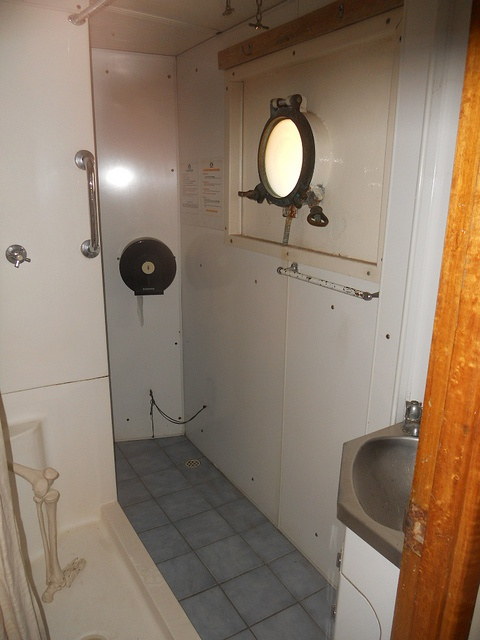Describe the objects in this image and their specific colors. I can see a sink in gray and black tones in this image. 